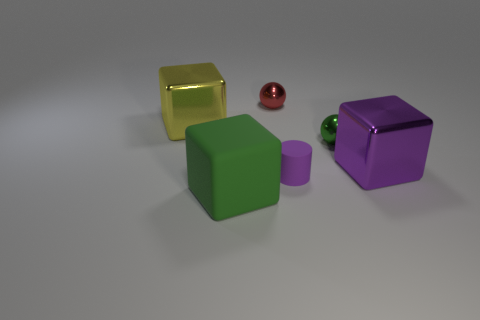Add 1 big yellow blocks. How many objects exist? 7 Subtract all cylinders. How many objects are left? 5 Subtract all large balls. Subtract all purple metallic things. How many objects are left? 5 Add 2 small purple matte things. How many small purple matte things are left? 3 Add 3 rubber blocks. How many rubber blocks exist? 4 Subtract 0 brown cylinders. How many objects are left? 6 